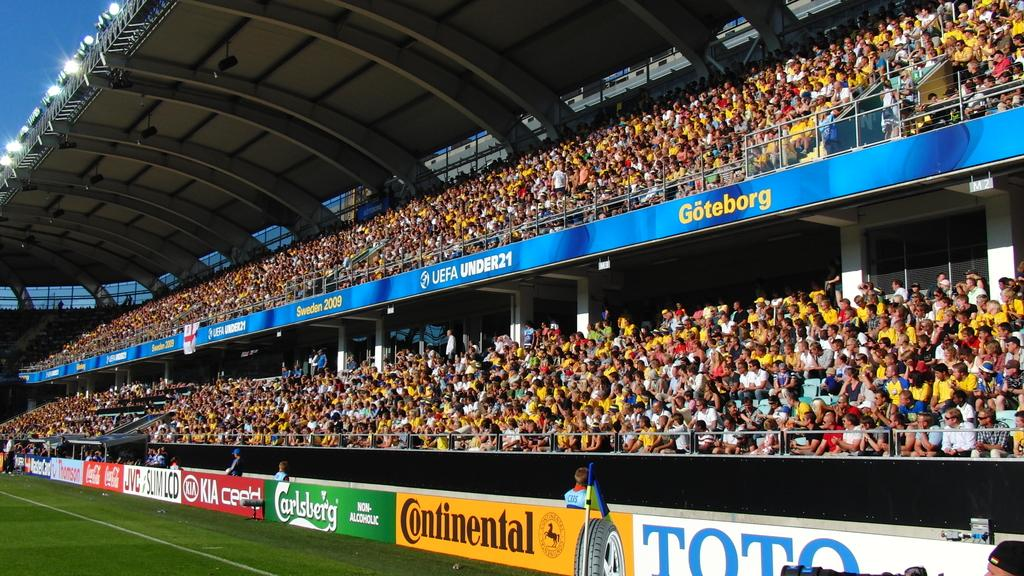Provide a one-sentence caption for the provided image. A crowded sports stadium with advertisements from Continental and Carlsberg. 